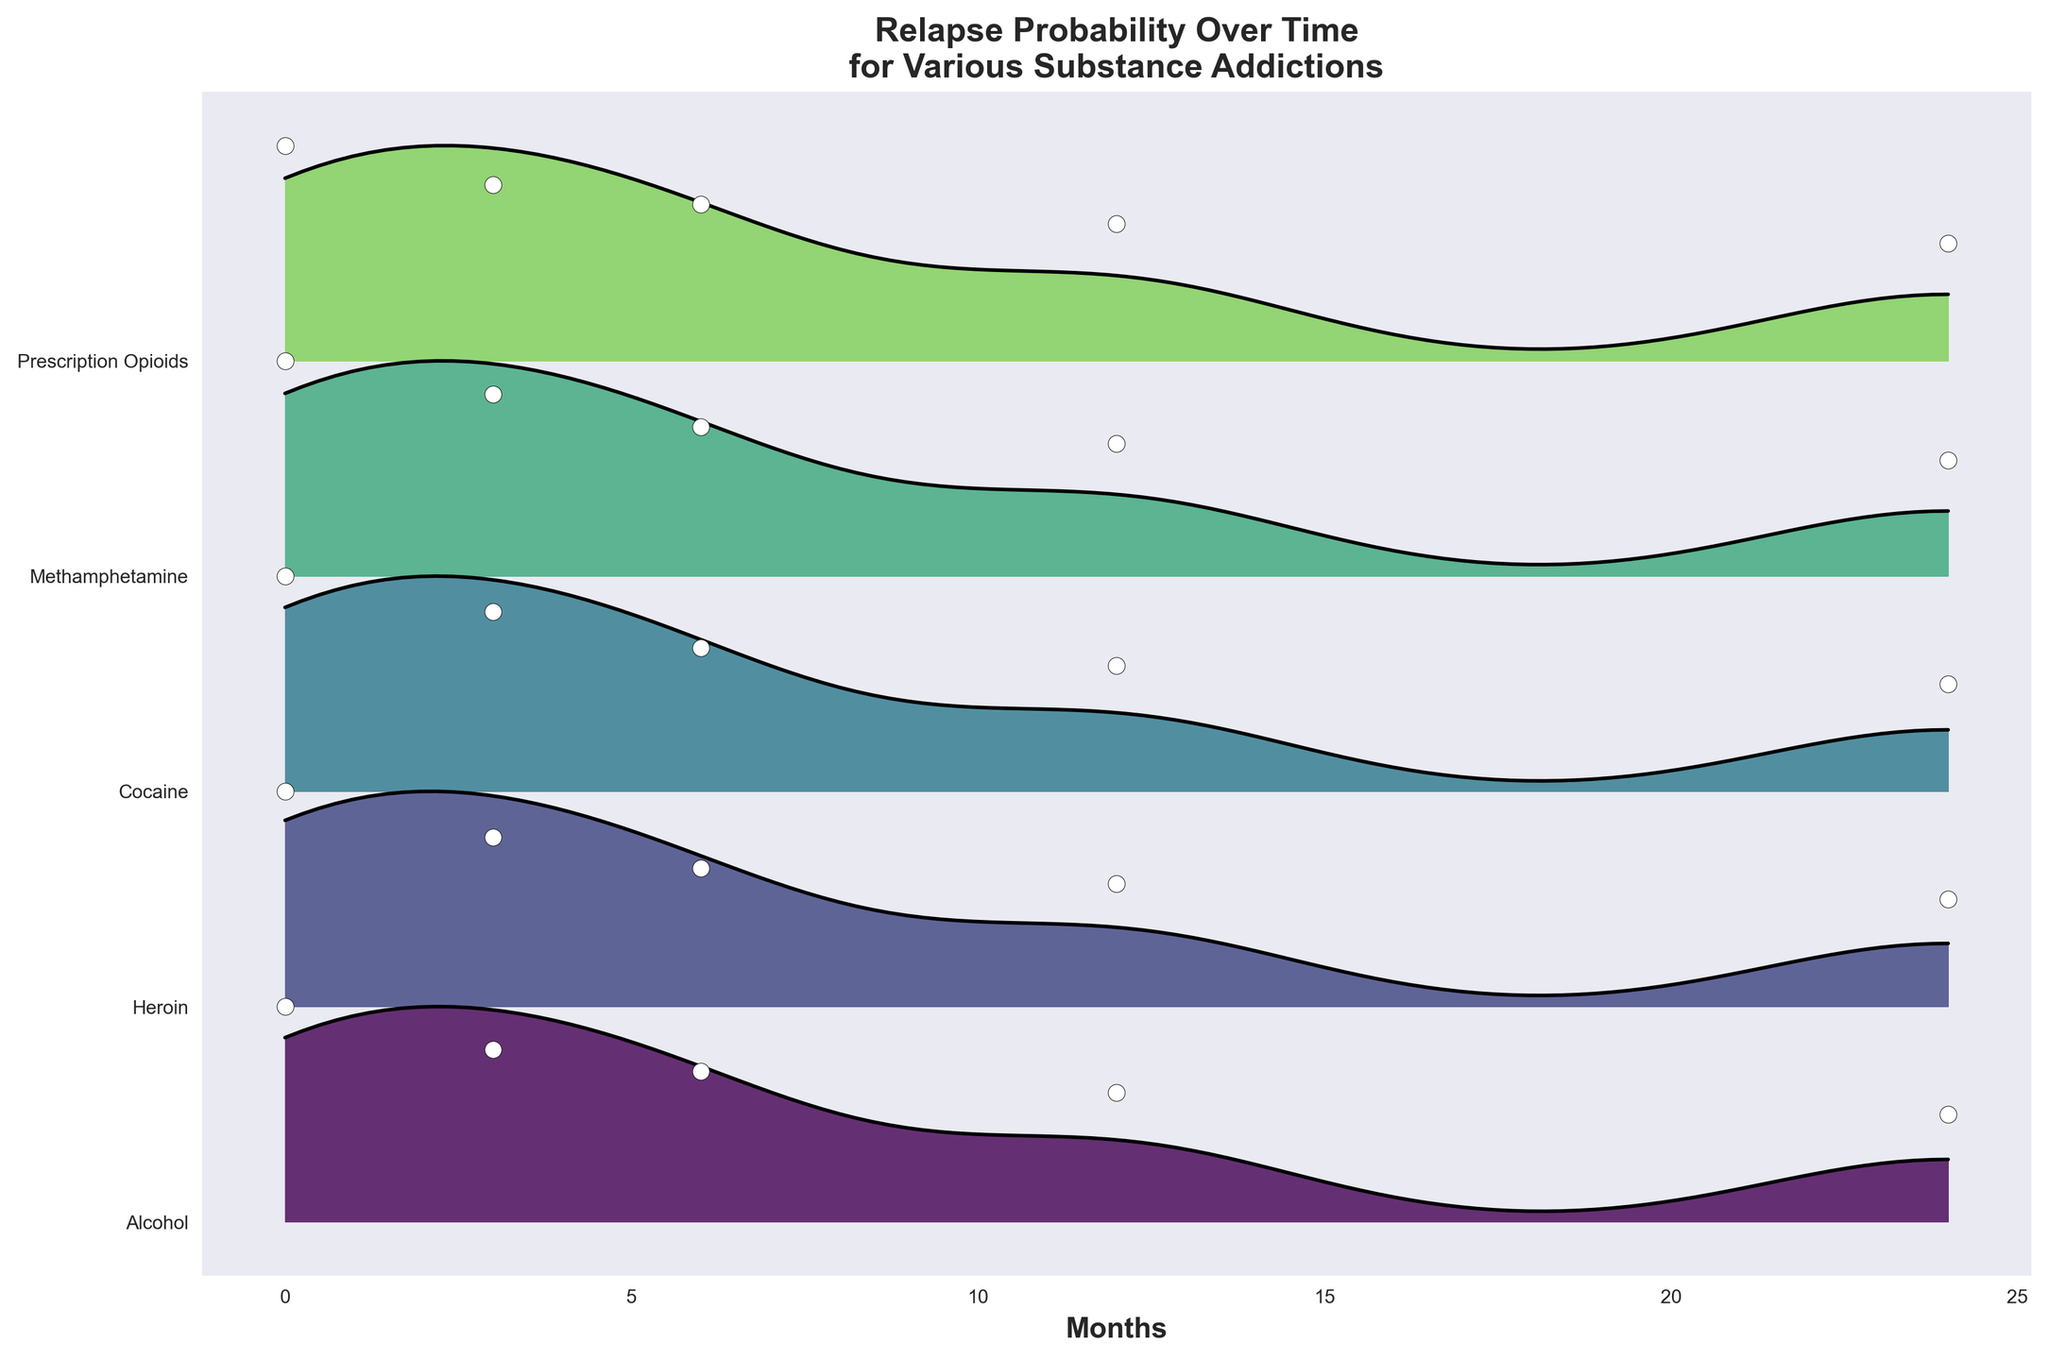Which substance has the highest relapse probability at the start of the observed period? At the start (Month 0), we compare the relapse probabilities for each substance. Heroin has the highest value at 0.70.
Answer: Heroin How does the relapse probability for Alcohol change from Month 0 to Month 24? The relapse probability for Alcohol decreases from 0.50 at Month 0 to 0.25 at Month 24. This decrease is observable as a downward slope over time.
Answer: Decreases Which substance shows the greatest reduction in relapse probability from Month 0 to Month 24? We need to calculate the difference between the relapse probabilities at Month 0 and Month 24 for all substances. Heroin shows a reduction from 0.70 to 0.35, a difference of 0.35. This is the greatest reduction among all substances.
Answer: Heroin Are there any substances that have an equal relapse probability at Month 12? We look at the relapse probabilities at Month 12. Both Cocaine and Methamphetamine have a probability of 0.40.
Answer: Cocaine, Methamphetamine What is the trend in relapse probability for Heroin from Month 0 to Month 24? We track the values for Heroin over time: 0.70 (Month 0), 0.55 (Month 3), 0.45 (Month 6), 0.40 (Month 12), and 0.35 (Month 24). This shows a consistent downward trend.
Answer: Downward trend Which substance has the lowest relapse probability at Month 3? At Month 3, the lowest relapse probability is 0.40, which is for Alcohol.
Answer: Alcohol Compare the relapse probability for Cocaine and Methamphetamine at Month 6. Which is higher? At Month 6, Cocaine has a relapse probability of 0.40, while Methamphetamine has a probability of 0.45. Thus, Methamphetamine's relapse probability is higher.
Answer: Methamphetamine What can be inferred about the overall effectiveness of the treatments for Alcohol and Prescription Opioids over the 24 months? We observe that both Alcohol and Prescription Opioids show a decrease in relapse probability over time from 0.50 to 0.25 (Alcohol) and 0.55 to 0.30 (Prescription Opioids), indicating a positive effect of treatment over 24 months.
Answer: Positive effect Is there any point in time where all substances have a similar trend in relapse probability? From Month 0 to Month 24, all substances show a consistent downward trend in relapse probability, indicating the effectiveness of the treatment over time without major deviations.
Answer: Yes Which substance has the highest relapse probability at Month 24? At Month 24, Heroin has the highest relapse probability of 0.35 among all the substances.
Answer: Heroin 